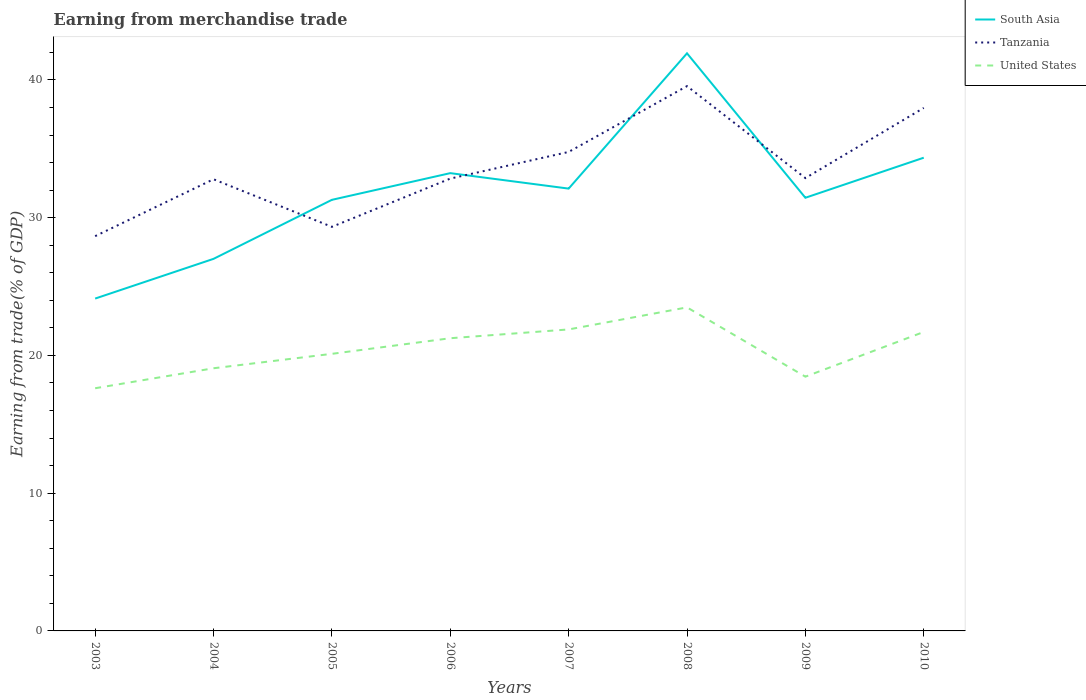Is the number of lines equal to the number of legend labels?
Give a very brief answer. Yes. Across all years, what is the maximum earnings from trade in Tanzania?
Give a very brief answer. 28.66. In which year was the earnings from trade in South Asia maximum?
Offer a terse response. 2003. What is the total earnings from trade in United States in the graph?
Keep it short and to the point. -3.37. What is the difference between the highest and the second highest earnings from trade in United States?
Provide a succinct answer. 5.87. What is the difference between the highest and the lowest earnings from trade in United States?
Ensure brevity in your answer.  4. How many lines are there?
Your response must be concise. 3. What is the difference between two consecutive major ticks on the Y-axis?
Provide a short and direct response. 10. Are the values on the major ticks of Y-axis written in scientific E-notation?
Provide a succinct answer. No. Does the graph contain any zero values?
Your answer should be compact. No. Where does the legend appear in the graph?
Your answer should be very brief. Top right. How many legend labels are there?
Provide a succinct answer. 3. How are the legend labels stacked?
Make the answer very short. Vertical. What is the title of the graph?
Provide a succinct answer. Earning from merchandise trade. Does "Bhutan" appear as one of the legend labels in the graph?
Ensure brevity in your answer.  No. What is the label or title of the X-axis?
Offer a terse response. Years. What is the label or title of the Y-axis?
Offer a very short reply. Earning from trade(% of GDP). What is the Earning from trade(% of GDP) of South Asia in 2003?
Keep it short and to the point. 24.13. What is the Earning from trade(% of GDP) in Tanzania in 2003?
Provide a succinct answer. 28.66. What is the Earning from trade(% of GDP) in United States in 2003?
Provide a short and direct response. 17.62. What is the Earning from trade(% of GDP) of South Asia in 2004?
Give a very brief answer. 27.01. What is the Earning from trade(% of GDP) in Tanzania in 2004?
Give a very brief answer. 32.79. What is the Earning from trade(% of GDP) of United States in 2004?
Offer a terse response. 19.07. What is the Earning from trade(% of GDP) in South Asia in 2005?
Your answer should be very brief. 31.29. What is the Earning from trade(% of GDP) of Tanzania in 2005?
Ensure brevity in your answer.  29.33. What is the Earning from trade(% of GDP) in United States in 2005?
Make the answer very short. 20.11. What is the Earning from trade(% of GDP) in South Asia in 2006?
Your answer should be compact. 33.23. What is the Earning from trade(% of GDP) of Tanzania in 2006?
Ensure brevity in your answer.  32.84. What is the Earning from trade(% of GDP) in United States in 2006?
Offer a very short reply. 21.25. What is the Earning from trade(% of GDP) in South Asia in 2007?
Offer a very short reply. 32.11. What is the Earning from trade(% of GDP) of Tanzania in 2007?
Provide a succinct answer. 34.77. What is the Earning from trade(% of GDP) in United States in 2007?
Your response must be concise. 21.89. What is the Earning from trade(% of GDP) of South Asia in 2008?
Make the answer very short. 41.93. What is the Earning from trade(% of GDP) in Tanzania in 2008?
Keep it short and to the point. 39.55. What is the Earning from trade(% of GDP) of United States in 2008?
Keep it short and to the point. 23.49. What is the Earning from trade(% of GDP) in South Asia in 2009?
Your answer should be very brief. 31.44. What is the Earning from trade(% of GDP) in Tanzania in 2009?
Your answer should be very brief. 32.87. What is the Earning from trade(% of GDP) in United States in 2009?
Make the answer very short. 18.46. What is the Earning from trade(% of GDP) in South Asia in 2010?
Your answer should be very brief. 34.35. What is the Earning from trade(% of GDP) of Tanzania in 2010?
Your answer should be compact. 37.97. What is the Earning from trade(% of GDP) of United States in 2010?
Your response must be concise. 21.7. Across all years, what is the maximum Earning from trade(% of GDP) of South Asia?
Your answer should be very brief. 41.93. Across all years, what is the maximum Earning from trade(% of GDP) of Tanzania?
Your answer should be compact. 39.55. Across all years, what is the maximum Earning from trade(% of GDP) in United States?
Ensure brevity in your answer.  23.49. Across all years, what is the minimum Earning from trade(% of GDP) of South Asia?
Provide a short and direct response. 24.13. Across all years, what is the minimum Earning from trade(% of GDP) of Tanzania?
Give a very brief answer. 28.66. Across all years, what is the minimum Earning from trade(% of GDP) of United States?
Offer a terse response. 17.62. What is the total Earning from trade(% of GDP) in South Asia in the graph?
Provide a short and direct response. 255.5. What is the total Earning from trade(% of GDP) in Tanzania in the graph?
Provide a succinct answer. 268.78. What is the total Earning from trade(% of GDP) of United States in the graph?
Provide a short and direct response. 163.58. What is the difference between the Earning from trade(% of GDP) in South Asia in 2003 and that in 2004?
Your answer should be very brief. -2.88. What is the difference between the Earning from trade(% of GDP) in Tanzania in 2003 and that in 2004?
Your response must be concise. -4.13. What is the difference between the Earning from trade(% of GDP) in United States in 2003 and that in 2004?
Provide a short and direct response. -1.45. What is the difference between the Earning from trade(% of GDP) of South Asia in 2003 and that in 2005?
Your answer should be very brief. -7.17. What is the difference between the Earning from trade(% of GDP) in Tanzania in 2003 and that in 2005?
Keep it short and to the point. -0.68. What is the difference between the Earning from trade(% of GDP) of United States in 2003 and that in 2005?
Your answer should be compact. -2.5. What is the difference between the Earning from trade(% of GDP) of South Asia in 2003 and that in 2006?
Your answer should be compact. -9.11. What is the difference between the Earning from trade(% of GDP) of Tanzania in 2003 and that in 2006?
Offer a terse response. -4.18. What is the difference between the Earning from trade(% of GDP) in United States in 2003 and that in 2006?
Ensure brevity in your answer.  -3.63. What is the difference between the Earning from trade(% of GDP) in South Asia in 2003 and that in 2007?
Your answer should be compact. -7.98. What is the difference between the Earning from trade(% of GDP) in Tanzania in 2003 and that in 2007?
Keep it short and to the point. -6.11. What is the difference between the Earning from trade(% of GDP) of United States in 2003 and that in 2007?
Your answer should be compact. -4.27. What is the difference between the Earning from trade(% of GDP) in South Asia in 2003 and that in 2008?
Provide a succinct answer. -17.8. What is the difference between the Earning from trade(% of GDP) of Tanzania in 2003 and that in 2008?
Provide a succinct answer. -10.89. What is the difference between the Earning from trade(% of GDP) of United States in 2003 and that in 2008?
Provide a short and direct response. -5.87. What is the difference between the Earning from trade(% of GDP) in South Asia in 2003 and that in 2009?
Provide a succinct answer. -7.32. What is the difference between the Earning from trade(% of GDP) of Tanzania in 2003 and that in 2009?
Give a very brief answer. -4.22. What is the difference between the Earning from trade(% of GDP) in United States in 2003 and that in 2009?
Make the answer very short. -0.84. What is the difference between the Earning from trade(% of GDP) of South Asia in 2003 and that in 2010?
Keep it short and to the point. -10.23. What is the difference between the Earning from trade(% of GDP) of Tanzania in 2003 and that in 2010?
Provide a short and direct response. -9.31. What is the difference between the Earning from trade(% of GDP) in United States in 2003 and that in 2010?
Provide a short and direct response. -4.09. What is the difference between the Earning from trade(% of GDP) of South Asia in 2004 and that in 2005?
Your response must be concise. -4.28. What is the difference between the Earning from trade(% of GDP) of Tanzania in 2004 and that in 2005?
Give a very brief answer. 3.45. What is the difference between the Earning from trade(% of GDP) in United States in 2004 and that in 2005?
Provide a succinct answer. -1.05. What is the difference between the Earning from trade(% of GDP) of South Asia in 2004 and that in 2006?
Your answer should be very brief. -6.22. What is the difference between the Earning from trade(% of GDP) in Tanzania in 2004 and that in 2006?
Your response must be concise. -0.05. What is the difference between the Earning from trade(% of GDP) in United States in 2004 and that in 2006?
Keep it short and to the point. -2.18. What is the difference between the Earning from trade(% of GDP) in South Asia in 2004 and that in 2007?
Keep it short and to the point. -5.1. What is the difference between the Earning from trade(% of GDP) in Tanzania in 2004 and that in 2007?
Keep it short and to the point. -1.98. What is the difference between the Earning from trade(% of GDP) in United States in 2004 and that in 2007?
Make the answer very short. -2.82. What is the difference between the Earning from trade(% of GDP) in South Asia in 2004 and that in 2008?
Your response must be concise. -14.92. What is the difference between the Earning from trade(% of GDP) of Tanzania in 2004 and that in 2008?
Keep it short and to the point. -6.76. What is the difference between the Earning from trade(% of GDP) of United States in 2004 and that in 2008?
Your response must be concise. -4.42. What is the difference between the Earning from trade(% of GDP) of South Asia in 2004 and that in 2009?
Offer a terse response. -4.44. What is the difference between the Earning from trade(% of GDP) of Tanzania in 2004 and that in 2009?
Make the answer very short. -0.09. What is the difference between the Earning from trade(% of GDP) of United States in 2004 and that in 2009?
Your response must be concise. 0.61. What is the difference between the Earning from trade(% of GDP) of South Asia in 2004 and that in 2010?
Make the answer very short. -7.34. What is the difference between the Earning from trade(% of GDP) of Tanzania in 2004 and that in 2010?
Keep it short and to the point. -5.18. What is the difference between the Earning from trade(% of GDP) in United States in 2004 and that in 2010?
Your answer should be compact. -2.63. What is the difference between the Earning from trade(% of GDP) of South Asia in 2005 and that in 2006?
Offer a terse response. -1.94. What is the difference between the Earning from trade(% of GDP) of Tanzania in 2005 and that in 2006?
Offer a terse response. -3.5. What is the difference between the Earning from trade(% of GDP) in United States in 2005 and that in 2006?
Offer a very short reply. -1.13. What is the difference between the Earning from trade(% of GDP) in South Asia in 2005 and that in 2007?
Make the answer very short. -0.81. What is the difference between the Earning from trade(% of GDP) in Tanzania in 2005 and that in 2007?
Keep it short and to the point. -5.44. What is the difference between the Earning from trade(% of GDP) of United States in 2005 and that in 2007?
Your answer should be very brief. -1.77. What is the difference between the Earning from trade(% of GDP) of South Asia in 2005 and that in 2008?
Keep it short and to the point. -10.64. What is the difference between the Earning from trade(% of GDP) in Tanzania in 2005 and that in 2008?
Offer a terse response. -10.21. What is the difference between the Earning from trade(% of GDP) in United States in 2005 and that in 2008?
Make the answer very short. -3.37. What is the difference between the Earning from trade(% of GDP) in South Asia in 2005 and that in 2009?
Your answer should be compact. -0.15. What is the difference between the Earning from trade(% of GDP) in Tanzania in 2005 and that in 2009?
Ensure brevity in your answer.  -3.54. What is the difference between the Earning from trade(% of GDP) of United States in 2005 and that in 2009?
Your answer should be compact. 1.66. What is the difference between the Earning from trade(% of GDP) in South Asia in 2005 and that in 2010?
Keep it short and to the point. -3.06. What is the difference between the Earning from trade(% of GDP) of Tanzania in 2005 and that in 2010?
Offer a very short reply. -8.63. What is the difference between the Earning from trade(% of GDP) of United States in 2005 and that in 2010?
Your answer should be very brief. -1.59. What is the difference between the Earning from trade(% of GDP) of South Asia in 2006 and that in 2007?
Your answer should be very brief. 1.12. What is the difference between the Earning from trade(% of GDP) in Tanzania in 2006 and that in 2007?
Provide a succinct answer. -1.94. What is the difference between the Earning from trade(% of GDP) in United States in 2006 and that in 2007?
Provide a succinct answer. -0.64. What is the difference between the Earning from trade(% of GDP) of South Asia in 2006 and that in 2008?
Your answer should be very brief. -8.7. What is the difference between the Earning from trade(% of GDP) in Tanzania in 2006 and that in 2008?
Offer a terse response. -6.71. What is the difference between the Earning from trade(% of GDP) of United States in 2006 and that in 2008?
Keep it short and to the point. -2.24. What is the difference between the Earning from trade(% of GDP) in South Asia in 2006 and that in 2009?
Your response must be concise. 1.79. What is the difference between the Earning from trade(% of GDP) of Tanzania in 2006 and that in 2009?
Keep it short and to the point. -0.04. What is the difference between the Earning from trade(% of GDP) of United States in 2006 and that in 2009?
Keep it short and to the point. 2.79. What is the difference between the Earning from trade(% of GDP) of South Asia in 2006 and that in 2010?
Give a very brief answer. -1.12. What is the difference between the Earning from trade(% of GDP) in Tanzania in 2006 and that in 2010?
Your response must be concise. -5.13. What is the difference between the Earning from trade(% of GDP) of United States in 2006 and that in 2010?
Your response must be concise. -0.46. What is the difference between the Earning from trade(% of GDP) in South Asia in 2007 and that in 2008?
Provide a short and direct response. -9.82. What is the difference between the Earning from trade(% of GDP) of Tanzania in 2007 and that in 2008?
Your response must be concise. -4.78. What is the difference between the Earning from trade(% of GDP) of United States in 2007 and that in 2008?
Your answer should be compact. -1.6. What is the difference between the Earning from trade(% of GDP) of South Asia in 2007 and that in 2009?
Your answer should be compact. 0.66. What is the difference between the Earning from trade(% of GDP) of Tanzania in 2007 and that in 2009?
Your response must be concise. 1.9. What is the difference between the Earning from trade(% of GDP) of United States in 2007 and that in 2009?
Offer a very short reply. 3.43. What is the difference between the Earning from trade(% of GDP) in South Asia in 2007 and that in 2010?
Your response must be concise. -2.24. What is the difference between the Earning from trade(% of GDP) in Tanzania in 2007 and that in 2010?
Provide a short and direct response. -3.2. What is the difference between the Earning from trade(% of GDP) in United States in 2007 and that in 2010?
Provide a short and direct response. 0.18. What is the difference between the Earning from trade(% of GDP) of South Asia in 2008 and that in 2009?
Keep it short and to the point. 10.48. What is the difference between the Earning from trade(% of GDP) of Tanzania in 2008 and that in 2009?
Offer a very short reply. 6.67. What is the difference between the Earning from trade(% of GDP) of United States in 2008 and that in 2009?
Provide a succinct answer. 5.03. What is the difference between the Earning from trade(% of GDP) of South Asia in 2008 and that in 2010?
Your response must be concise. 7.58. What is the difference between the Earning from trade(% of GDP) of Tanzania in 2008 and that in 2010?
Keep it short and to the point. 1.58. What is the difference between the Earning from trade(% of GDP) of United States in 2008 and that in 2010?
Provide a succinct answer. 1.78. What is the difference between the Earning from trade(% of GDP) of South Asia in 2009 and that in 2010?
Ensure brevity in your answer.  -2.91. What is the difference between the Earning from trade(% of GDP) in Tanzania in 2009 and that in 2010?
Your answer should be very brief. -5.09. What is the difference between the Earning from trade(% of GDP) in United States in 2009 and that in 2010?
Your answer should be compact. -3.25. What is the difference between the Earning from trade(% of GDP) of South Asia in 2003 and the Earning from trade(% of GDP) of Tanzania in 2004?
Your response must be concise. -8.66. What is the difference between the Earning from trade(% of GDP) in South Asia in 2003 and the Earning from trade(% of GDP) in United States in 2004?
Keep it short and to the point. 5.06. What is the difference between the Earning from trade(% of GDP) of Tanzania in 2003 and the Earning from trade(% of GDP) of United States in 2004?
Offer a terse response. 9.59. What is the difference between the Earning from trade(% of GDP) in South Asia in 2003 and the Earning from trade(% of GDP) in Tanzania in 2005?
Ensure brevity in your answer.  -5.21. What is the difference between the Earning from trade(% of GDP) in South Asia in 2003 and the Earning from trade(% of GDP) in United States in 2005?
Your answer should be compact. 4.01. What is the difference between the Earning from trade(% of GDP) of Tanzania in 2003 and the Earning from trade(% of GDP) of United States in 2005?
Your response must be concise. 8.54. What is the difference between the Earning from trade(% of GDP) of South Asia in 2003 and the Earning from trade(% of GDP) of Tanzania in 2006?
Your answer should be compact. -8.71. What is the difference between the Earning from trade(% of GDP) in South Asia in 2003 and the Earning from trade(% of GDP) in United States in 2006?
Ensure brevity in your answer.  2.88. What is the difference between the Earning from trade(% of GDP) of Tanzania in 2003 and the Earning from trade(% of GDP) of United States in 2006?
Provide a succinct answer. 7.41. What is the difference between the Earning from trade(% of GDP) of South Asia in 2003 and the Earning from trade(% of GDP) of Tanzania in 2007?
Give a very brief answer. -10.64. What is the difference between the Earning from trade(% of GDP) in South Asia in 2003 and the Earning from trade(% of GDP) in United States in 2007?
Your answer should be compact. 2.24. What is the difference between the Earning from trade(% of GDP) of Tanzania in 2003 and the Earning from trade(% of GDP) of United States in 2007?
Keep it short and to the point. 6.77. What is the difference between the Earning from trade(% of GDP) in South Asia in 2003 and the Earning from trade(% of GDP) in Tanzania in 2008?
Provide a succinct answer. -15.42. What is the difference between the Earning from trade(% of GDP) of South Asia in 2003 and the Earning from trade(% of GDP) of United States in 2008?
Ensure brevity in your answer.  0.64. What is the difference between the Earning from trade(% of GDP) in Tanzania in 2003 and the Earning from trade(% of GDP) in United States in 2008?
Provide a short and direct response. 5.17. What is the difference between the Earning from trade(% of GDP) of South Asia in 2003 and the Earning from trade(% of GDP) of Tanzania in 2009?
Your response must be concise. -8.75. What is the difference between the Earning from trade(% of GDP) of South Asia in 2003 and the Earning from trade(% of GDP) of United States in 2009?
Provide a short and direct response. 5.67. What is the difference between the Earning from trade(% of GDP) in Tanzania in 2003 and the Earning from trade(% of GDP) in United States in 2009?
Offer a terse response. 10.2. What is the difference between the Earning from trade(% of GDP) of South Asia in 2003 and the Earning from trade(% of GDP) of Tanzania in 2010?
Offer a terse response. -13.84. What is the difference between the Earning from trade(% of GDP) of South Asia in 2003 and the Earning from trade(% of GDP) of United States in 2010?
Make the answer very short. 2.42. What is the difference between the Earning from trade(% of GDP) of Tanzania in 2003 and the Earning from trade(% of GDP) of United States in 2010?
Provide a short and direct response. 6.96. What is the difference between the Earning from trade(% of GDP) in South Asia in 2004 and the Earning from trade(% of GDP) in Tanzania in 2005?
Provide a short and direct response. -2.32. What is the difference between the Earning from trade(% of GDP) in South Asia in 2004 and the Earning from trade(% of GDP) in United States in 2005?
Your response must be concise. 6.89. What is the difference between the Earning from trade(% of GDP) of Tanzania in 2004 and the Earning from trade(% of GDP) of United States in 2005?
Offer a terse response. 12.67. What is the difference between the Earning from trade(% of GDP) in South Asia in 2004 and the Earning from trade(% of GDP) in Tanzania in 2006?
Keep it short and to the point. -5.83. What is the difference between the Earning from trade(% of GDP) of South Asia in 2004 and the Earning from trade(% of GDP) of United States in 2006?
Your answer should be very brief. 5.76. What is the difference between the Earning from trade(% of GDP) in Tanzania in 2004 and the Earning from trade(% of GDP) in United States in 2006?
Keep it short and to the point. 11.54. What is the difference between the Earning from trade(% of GDP) in South Asia in 2004 and the Earning from trade(% of GDP) in Tanzania in 2007?
Give a very brief answer. -7.76. What is the difference between the Earning from trade(% of GDP) in South Asia in 2004 and the Earning from trade(% of GDP) in United States in 2007?
Give a very brief answer. 5.12. What is the difference between the Earning from trade(% of GDP) of Tanzania in 2004 and the Earning from trade(% of GDP) of United States in 2007?
Make the answer very short. 10.9. What is the difference between the Earning from trade(% of GDP) of South Asia in 2004 and the Earning from trade(% of GDP) of Tanzania in 2008?
Ensure brevity in your answer.  -12.54. What is the difference between the Earning from trade(% of GDP) in South Asia in 2004 and the Earning from trade(% of GDP) in United States in 2008?
Provide a short and direct response. 3.52. What is the difference between the Earning from trade(% of GDP) of Tanzania in 2004 and the Earning from trade(% of GDP) of United States in 2008?
Make the answer very short. 9.3. What is the difference between the Earning from trade(% of GDP) in South Asia in 2004 and the Earning from trade(% of GDP) in Tanzania in 2009?
Your response must be concise. -5.86. What is the difference between the Earning from trade(% of GDP) of South Asia in 2004 and the Earning from trade(% of GDP) of United States in 2009?
Keep it short and to the point. 8.55. What is the difference between the Earning from trade(% of GDP) in Tanzania in 2004 and the Earning from trade(% of GDP) in United States in 2009?
Ensure brevity in your answer.  14.33. What is the difference between the Earning from trade(% of GDP) of South Asia in 2004 and the Earning from trade(% of GDP) of Tanzania in 2010?
Your answer should be compact. -10.96. What is the difference between the Earning from trade(% of GDP) in South Asia in 2004 and the Earning from trade(% of GDP) in United States in 2010?
Keep it short and to the point. 5.31. What is the difference between the Earning from trade(% of GDP) of Tanzania in 2004 and the Earning from trade(% of GDP) of United States in 2010?
Offer a very short reply. 11.09. What is the difference between the Earning from trade(% of GDP) in South Asia in 2005 and the Earning from trade(% of GDP) in Tanzania in 2006?
Give a very brief answer. -1.54. What is the difference between the Earning from trade(% of GDP) in South Asia in 2005 and the Earning from trade(% of GDP) in United States in 2006?
Provide a succinct answer. 10.05. What is the difference between the Earning from trade(% of GDP) of Tanzania in 2005 and the Earning from trade(% of GDP) of United States in 2006?
Your answer should be compact. 8.09. What is the difference between the Earning from trade(% of GDP) of South Asia in 2005 and the Earning from trade(% of GDP) of Tanzania in 2007?
Offer a terse response. -3.48. What is the difference between the Earning from trade(% of GDP) of South Asia in 2005 and the Earning from trade(% of GDP) of United States in 2007?
Provide a succinct answer. 9.41. What is the difference between the Earning from trade(% of GDP) of Tanzania in 2005 and the Earning from trade(% of GDP) of United States in 2007?
Keep it short and to the point. 7.45. What is the difference between the Earning from trade(% of GDP) in South Asia in 2005 and the Earning from trade(% of GDP) in Tanzania in 2008?
Ensure brevity in your answer.  -8.25. What is the difference between the Earning from trade(% of GDP) in South Asia in 2005 and the Earning from trade(% of GDP) in United States in 2008?
Your answer should be very brief. 7.81. What is the difference between the Earning from trade(% of GDP) in Tanzania in 2005 and the Earning from trade(% of GDP) in United States in 2008?
Ensure brevity in your answer.  5.85. What is the difference between the Earning from trade(% of GDP) in South Asia in 2005 and the Earning from trade(% of GDP) in Tanzania in 2009?
Offer a terse response. -1.58. What is the difference between the Earning from trade(% of GDP) of South Asia in 2005 and the Earning from trade(% of GDP) of United States in 2009?
Ensure brevity in your answer.  12.84. What is the difference between the Earning from trade(% of GDP) of Tanzania in 2005 and the Earning from trade(% of GDP) of United States in 2009?
Offer a terse response. 10.88. What is the difference between the Earning from trade(% of GDP) in South Asia in 2005 and the Earning from trade(% of GDP) in Tanzania in 2010?
Keep it short and to the point. -6.67. What is the difference between the Earning from trade(% of GDP) in South Asia in 2005 and the Earning from trade(% of GDP) in United States in 2010?
Offer a terse response. 9.59. What is the difference between the Earning from trade(% of GDP) in Tanzania in 2005 and the Earning from trade(% of GDP) in United States in 2010?
Give a very brief answer. 7.63. What is the difference between the Earning from trade(% of GDP) in South Asia in 2006 and the Earning from trade(% of GDP) in Tanzania in 2007?
Give a very brief answer. -1.54. What is the difference between the Earning from trade(% of GDP) of South Asia in 2006 and the Earning from trade(% of GDP) of United States in 2007?
Offer a terse response. 11.35. What is the difference between the Earning from trade(% of GDP) of Tanzania in 2006 and the Earning from trade(% of GDP) of United States in 2007?
Offer a terse response. 10.95. What is the difference between the Earning from trade(% of GDP) in South Asia in 2006 and the Earning from trade(% of GDP) in Tanzania in 2008?
Your answer should be compact. -6.32. What is the difference between the Earning from trade(% of GDP) of South Asia in 2006 and the Earning from trade(% of GDP) of United States in 2008?
Your answer should be very brief. 9.74. What is the difference between the Earning from trade(% of GDP) in Tanzania in 2006 and the Earning from trade(% of GDP) in United States in 2008?
Your answer should be very brief. 9.35. What is the difference between the Earning from trade(% of GDP) in South Asia in 2006 and the Earning from trade(% of GDP) in Tanzania in 2009?
Ensure brevity in your answer.  0.36. What is the difference between the Earning from trade(% of GDP) of South Asia in 2006 and the Earning from trade(% of GDP) of United States in 2009?
Your answer should be compact. 14.77. What is the difference between the Earning from trade(% of GDP) of Tanzania in 2006 and the Earning from trade(% of GDP) of United States in 2009?
Offer a terse response. 14.38. What is the difference between the Earning from trade(% of GDP) in South Asia in 2006 and the Earning from trade(% of GDP) in Tanzania in 2010?
Provide a succinct answer. -4.74. What is the difference between the Earning from trade(% of GDP) of South Asia in 2006 and the Earning from trade(% of GDP) of United States in 2010?
Your response must be concise. 11.53. What is the difference between the Earning from trade(% of GDP) of Tanzania in 2006 and the Earning from trade(% of GDP) of United States in 2010?
Give a very brief answer. 11.13. What is the difference between the Earning from trade(% of GDP) of South Asia in 2007 and the Earning from trade(% of GDP) of Tanzania in 2008?
Provide a succinct answer. -7.44. What is the difference between the Earning from trade(% of GDP) of South Asia in 2007 and the Earning from trade(% of GDP) of United States in 2008?
Your answer should be very brief. 8.62. What is the difference between the Earning from trade(% of GDP) in Tanzania in 2007 and the Earning from trade(% of GDP) in United States in 2008?
Your response must be concise. 11.28. What is the difference between the Earning from trade(% of GDP) of South Asia in 2007 and the Earning from trade(% of GDP) of Tanzania in 2009?
Keep it short and to the point. -0.76. What is the difference between the Earning from trade(% of GDP) in South Asia in 2007 and the Earning from trade(% of GDP) in United States in 2009?
Provide a short and direct response. 13.65. What is the difference between the Earning from trade(% of GDP) of Tanzania in 2007 and the Earning from trade(% of GDP) of United States in 2009?
Keep it short and to the point. 16.31. What is the difference between the Earning from trade(% of GDP) in South Asia in 2007 and the Earning from trade(% of GDP) in Tanzania in 2010?
Provide a succinct answer. -5.86. What is the difference between the Earning from trade(% of GDP) of South Asia in 2007 and the Earning from trade(% of GDP) of United States in 2010?
Provide a short and direct response. 10.41. What is the difference between the Earning from trade(% of GDP) in Tanzania in 2007 and the Earning from trade(% of GDP) in United States in 2010?
Offer a terse response. 13.07. What is the difference between the Earning from trade(% of GDP) of South Asia in 2008 and the Earning from trade(% of GDP) of Tanzania in 2009?
Provide a short and direct response. 9.06. What is the difference between the Earning from trade(% of GDP) in South Asia in 2008 and the Earning from trade(% of GDP) in United States in 2009?
Give a very brief answer. 23.47. What is the difference between the Earning from trade(% of GDP) in Tanzania in 2008 and the Earning from trade(% of GDP) in United States in 2009?
Offer a very short reply. 21.09. What is the difference between the Earning from trade(% of GDP) in South Asia in 2008 and the Earning from trade(% of GDP) in Tanzania in 2010?
Give a very brief answer. 3.96. What is the difference between the Earning from trade(% of GDP) of South Asia in 2008 and the Earning from trade(% of GDP) of United States in 2010?
Your answer should be compact. 20.23. What is the difference between the Earning from trade(% of GDP) of Tanzania in 2008 and the Earning from trade(% of GDP) of United States in 2010?
Ensure brevity in your answer.  17.85. What is the difference between the Earning from trade(% of GDP) of South Asia in 2009 and the Earning from trade(% of GDP) of Tanzania in 2010?
Provide a short and direct response. -6.52. What is the difference between the Earning from trade(% of GDP) in South Asia in 2009 and the Earning from trade(% of GDP) in United States in 2010?
Offer a very short reply. 9.74. What is the difference between the Earning from trade(% of GDP) of Tanzania in 2009 and the Earning from trade(% of GDP) of United States in 2010?
Your answer should be compact. 11.17. What is the average Earning from trade(% of GDP) in South Asia per year?
Your response must be concise. 31.94. What is the average Earning from trade(% of GDP) of Tanzania per year?
Provide a succinct answer. 33.6. What is the average Earning from trade(% of GDP) of United States per year?
Your answer should be very brief. 20.45. In the year 2003, what is the difference between the Earning from trade(% of GDP) in South Asia and Earning from trade(% of GDP) in Tanzania?
Offer a terse response. -4.53. In the year 2003, what is the difference between the Earning from trade(% of GDP) in South Asia and Earning from trade(% of GDP) in United States?
Your answer should be very brief. 6.51. In the year 2003, what is the difference between the Earning from trade(% of GDP) in Tanzania and Earning from trade(% of GDP) in United States?
Keep it short and to the point. 11.04. In the year 2004, what is the difference between the Earning from trade(% of GDP) in South Asia and Earning from trade(% of GDP) in Tanzania?
Offer a terse response. -5.78. In the year 2004, what is the difference between the Earning from trade(% of GDP) of South Asia and Earning from trade(% of GDP) of United States?
Give a very brief answer. 7.94. In the year 2004, what is the difference between the Earning from trade(% of GDP) in Tanzania and Earning from trade(% of GDP) in United States?
Your response must be concise. 13.72. In the year 2005, what is the difference between the Earning from trade(% of GDP) of South Asia and Earning from trade(% of GDP) of Tanzania?
Ensure brevity in your answer.  1.96. In the year 2005, what is the difference between the Earning from trade(% of GDP) in South Asia and Earning from trade(% of GDP) in United States?
Offer a terse response. 11.18. In the year 2005, what is the difference between the Earning from trade(% of GDP) in Tanzania and Earning from trade(% of GDP) in United States?
Offer a very short reply. 9.22. In the year 2006, what is the difference between the Earning from trade(% of GDP) of South Asia and Earning from trade(% of GDP) of Tanzania?
Provide a short and direct response. 0.4. In the year 2006, what is the difference between the Earning from trade(% of GDP) of South Asia and Earning from trade(% of GDP) of United States?
Offer a very short reply. 11.98. In the year 2006, what is the difference between the Earning from trade(% of GDP) of Tanzania and Earning from trade(% of GDP) of United States?
Offer a very short reply. 11.59. In the year 2007, what is the difference between the Earning from trade(% of GDP) in South Asia and Earning from trade(% of GDP) in Tanzania?
Offer a very short reply. -2.66. In the year 2007, what is the difference between the Earning from trade(% of GDP) of South Asia and Earning from trade(% of GDP) of United States?
Provide a succinct answer. 10.22. In the year 2007, what is the difference between the Earning from trade(% of GDP) in Tanzania and Earning from trade(% of GDP) in United States?
Provide a short and direct response. 12.88. In the year 2008, what is the difference between the Earning from trade(% of GDP) in South Asia and Earning from trade(% of GDP) in Tanzania?
Keep it short and to the point. 2.38. In the year 2008, what is the difference between the Earning from trade(% of GDP) in South Asia and Earning from trade(% of GDP) in United States?
Your answer should be compact. 18.44. In the year 2008, what is the difference between the Earning from trade(% of GDP) of Tanzania and Earning from trade(% of GDP) of United States?
Keep it short and to the point. 16.06. In the year 2009, what is the difference between the Earning from trade(% of GDP) of South Asia and Earning from trade(% of GDP) of Tanzania?
Provide a succinct answer. -1.43. In the year 2009, what is the difference between the Earning from trade(% of GDP) in South Asia and Earning from trade(% of GDP) in United States?
Your answer should be compact. 12.99. In the year 2009, what is the difference between the Earning from trade(% of GDP) of Tanzania and Earning from trade(% of GDP) of United States?
Your response must be concise. 14.42. In the year 2010, what is the difference between the Earning from trade(% of GDP) of South Asia and Earning from trade(% of GDP) of Tanzania?
Offer a very short reply. -3.61. In the year 2010, what is the difference between the Earning from trade(% of GDP) of South Asia and Earning from trade(% of GDP) of United States?
Keep it short and to the point. 12.65. In the year 2010, what is the difference between the Earning from trade(% of GDP) in Tanzania and Earning from trade(% of GDP) in United States?
Offer a very short reply. 16.26. What is the ratio of the Earning from trade(% of GDP) in South Asia in 2003 to that in 2004?
Ensure brevity in your answer.  0.89. What is the ratio of the Earning from trade(% of GDP) of Tanzania in 2003 to that in 2004?
Offer a very short reply. 0.87. What is the ratio of the Earning from trade(% of GDP) of United States in 2003 to that in 2004?
Ensure brevity in your answer.  0.92. What is the ratio of the Earning from trade(% of GDP) of South Asia in 2003 to that in 2005?
Keep it short and to the point. 0.77. What is the ratio of the Earning from trade(% of GDP) in United States in 2003 to that in 2005?
Ensure brevity in your answer.  0.88. What is the ratio of the Earning from trade(% of GDP) of South Asia in 2003 to that in 2006?
Give a very brief answer. 0.73. What is the ratio of the Earning from trade(% of GDP) in Tanzania in 2003 to that in 2006?
Offer a very short reply. 0.87. What is the ratio of the Earning from trade(% of GDP) of United States in 2003 to that in 2006?
Keep it short and to the point. 0.83. What is the ratio of the Earning from trade(% of GDP) of South Asia in 2003 to that in 2007?
Your answer should be very brief. 0.75. What is the ratio of the Earning from trade(% of GDP) of Tanzania in 2003 to that in 2007?
Give a very brief answer. 0.82. What is the ratio of the Earning from trade(% of GDP) in United States in 2003 to that in 2007?
Make the answer very short. 0.8. What is the ratio of the Earning from trade(% of GDP) in South Asia in 2003 to that in 2008?
Ensure brevity in your answer.  0.58. What is the ratio of the Earning from trade(% of GDP) of Tanzania in 2003 to that in 2008?
Give a very brief answer. 0.72. What is the ratio of the Earning from trade(% of GDP) in United States in 2003 to that in 2008?
Your answer should be very brief. 0.75. What is the ratio of the Earning from trade(% of GDP) in South Asia in 2003 to that in 2009?
Provide a succinct answer. 0.77. What is the ratio of the Earning from trade(% of GDP) in Tanzania in 2003 to that in 2009?
Make the answer very short. 0.87. What is the ratio of the Earning from trade(% of GDP) in United States in 2003 to that in 2009?
Keep it short and to the point. 0.95. What is the ratio of the Earning from trade(% of GDP) in South Asia in 2003 to that in 2010?
Give a very brief answer. 0.7. What is the ratio of the Earning from trade(% of GDP) of Tanzania in 2003 to that in 2010?
Your response must be concise. 0.75. What is the ratio of the Earning from trade(% of GDP) in United States in 2003 to that in 2010?
Provide a short and direct response. 0.81. What is the ratio of the Earning from trade(% of GDP) in South Asia in 2004 to that in 2005?
Your answer should be compact. 0.86. What is the ratio of the Earning from trade(% of GDP) in Tanzania in 2004 to that in 2005?
Your answer should be compact. 1.12. What is the ratio of the Earning from trade(% of GDP) of United States in 2004 to that in 2005?
Offer a terse response. 0.95. What is the ratio of the Earning from trade(% of GDP) in South Asia in 2004 to that in 2006?
Your response must be concise. 0.81. What is the ratio of the Earning from trade(% of GDP) in United States in 2004 to that in 2006?
Offer a very short reply. 0.9. What is the ratio of the Earning from trade(% of GDP) in South Asia in 2004 to that in 2007?
Give a very brief answer. 0.84. What is the ratio of the Earning from trade(% of GDP) in Tanzania in 2004 to that in 2007?
Make the answer very short. 0.94. What is the ratio of the Earning from trade(% of GDP) of United States in 2004 to that in 2007?
Your response must be concise. 0.87. What is the ratio of the Earning from trade(% of GDP) of South Asia in 2004 to that in 2008?
Your answer should be compact. 0.64. What is the ratio of the Earning from trade(% of GDP) in Tanzania in 2004 to that in 2008?
Provide a succinct answer. 0.83. What is the ratio of the Earning from trade(% of GDP) in United States in 2004 to that in 2008?
Provide a succinct answer. 0.81. What is the ratio of the Earning from trade(% of GDP) in South Asia in 2004 to that in 2009?
Offer a very short reply. 0.86. What is the ratio of the Earning from trade(% of GDP) of Tanzania in 2004 to that in 2009?
Ensure brevity in your answer.  1. What is the ratio of the Earning from trade(% of GDP) in United States in 2004 to that in 2009?
Give a very brief answer. 1.03. What is the ratio of the Earning from trade(% of GDP) in South Asia in 2004 to that in 2010?
Ensure brevity in your answer.  0.79. What is the ratio of the Earning from trade(% of GDP) in Tanzania in 2004 to that in 2010?
Offer a terse response. 0.86. What is the ratio of the Earning from trade(% of GDP) of United States in 2004 to that in 2010?
Offer a terse response. 0.88. What is the ratio of the Earning from trade(% of GDP) of South Asia in 2005 to that in 2006?
Your answer should be compact. 0.94. What is the ratio of the Earning from trade(% of GDP) in Tanzania in 2005 to that in 2006?
Provide a succinct answer. 0.89. What is the ratio of the Earning from trade(% of GDP) of United States in 2005 to that in 2006?
Offer a terse response. 0.95. What is the ratio of the Earning from trade(% of GDP) in South Asia in 2005 to that in 2007?
Give a very brief answer. 0.97. What is the ratio of the Earning from trade(% of GDP) in Tanzania in 2005 to that in 2007?
Offer a terse response. 0.84. What is the ratio of the Earning from trade(% of GDP) of United States in 2005 to that in 2007?
Your answer should be very brief. 0.92. What is the ratio of the Earning from trade(% of GDP) of South Asia in 2005 to that in 2008?
Make the answer very short. 0.75. What is the ratio of the Earning from trade(% of GDP) in Tanzania in 2005 to that in 2008?
Offer a very short reply. 0.74. What is the ratio of the Earning from trade(% of GDP) in United States in 2005 to that in 2008?
Make the answer very short. 0.86. What is the ratio of the Earning from trade(% of GDP) of Tanzania in 2005 to that in 2009?
Make the answer very short. 0.89. What is the ratio of the Earning from trade(% of GDP) of United States in 2005 to that in 2009?
Give a very brief answer. 1.09. What is the ratio of the Earning from trade(% of GDP) of South Asia in 2005 to that in 2010?
Keep it short and to the point. 0.91. What is the ratio of the Earning from trade(% of GDP) in Tanzania in 2005 to that in 2010?
Make the answer very short. 0.77. What is the ratio of the Earning from trade(% of GDP) in United States in 2005 to that in 2010?
Offer a very short reply. 0.93. What is the ratio of the Earning from trade(% of GDP) in South Asia in 2006 to that in 2007?
Offer a very short reply. 1.03. What is the ratio of the Earning from trade(% of GDP) in Tanzania in 2006 to that in 2007?
Offer a very short reply. 0.94. What is the ratio of the Earning from trade(% of GDP) in United States in 2006 to that in 2007?
Your response must be concise. 0.97. What is the ratio of the Earning from trade(% of GDP) in South Asia in 2006 to that in 2008?
Offer a terse response. 0.79. What is the ratio of the Earning from trade(% of GDP) of Tanzania in 2006 to that in 2008?
Make the answer very short. 0.83. What is the ratio of the Earning from trade(% of GDP) in United States in 2006 to that in 2008?
Provide a succinct answer. 0.9. What is the ratio of the Earning from trade(% of GDP) of South Asia in 2006 to that in 2009?
Provide a short and direct response. 1.06. What is the ratio of the Earning from trade(% of GDP) in United States in 2006 to that in 2009?
Provide a short and direct response. 1.15. What is the ratio of the Earning from trade(% of GDP) in South Asia in 2006 to that in 2010?
Make the answer very short. 0.97. What is the ratio of the Earning from trade(% of GDP) in Tanzania in 2006 to that in 2010?
Provide a short and direct response. 0.86. What is the ratio of the Earning from trade(% of GDP) in South Asia in 2007 to that in 2008?
Provide a short and direct response. 0.77. What is the ratio of the Earning from trade(% of GDP) in Tanzania in 2007 to that in 2008?
Offer a terse response. 0.88. What is the ratio of the Earning from trade(% of GDP) in United States in 2007 to that in 2008?
Ensure brevity in your answer.  0.93. What is the ratio of the Earning from trade(% of GDP) in South Asia in 2007 to that in 2009?
Your answer should be very brief. 1.02. What is the ratio of the Earning from trade(% of GDP) in Tanzania in 2007 to that in 2009?
Ensure brevity in your answer.  1.06. What is the ratio of the Earning from trade(% of GDP) in United States in 2007 to that in 2009?
Keep it short and to the point. 1.19. What is the ratio of the Earning from trade(% of GDP) of South Asia in 2007 to that in 2010?
Make the answer very short. 0.93. What is the ratio of the Earning from trade(% of GDP) of Tanzania in 2007 to that in 2010?
Offer a terse response. 0.92. What is the ratio of the Earning from trade(% of GDP) in United States in 2007 to that in 2010?
Your answer should be compact. 1.01. What is the ratio of the Earning from trade(% of GDP) of South Asia in 2008 to that in 2009?
Give a very brief answer. 1.33. What is the ratio of the Earning from trade(% of GDP) of Tanzania in 2008 to that in 2009?
Your answer should be compact. 1.2. What is the ratio of the Earning from trade(% of GDP) in United States in 2008 to that in 2009?
Keep it short and to the point. 1.27. What is the ratio of the Earning from trade(% of GDP) of South Asia in 2008 to that in 2010?
Ensure brevity in your answer.  1.22. What is the ratio of the Earning from trade(% of GDP) in Tanzania in 2008 to that in 2010?
Your answer should be compact. 1.04. What is the ratio of the Earning from trade(% of GDP) of United States in 2008 to that in 2010?
Ensure brevity in your answer.  1.08. What is the ratio of the Earning from trade(% of GDP) in South Asia in 2009 to that in 2010?
Make the answer very short. 0.92. What is the ratio of the Earning from trade(% of GDP) of Tanzania in 2009 to that in 2010?
Your answer should be compact. 0.87. What is the ratio of the Earning from trade(% of GDP) of United States in 2009 to that in 2010?
Make the answer very short. 0.85. What is the difference between the highest and the second highest Earning from trade(% of GDP) of South Asia?
Ensure brevity in your answer.  7.58. What is the difference between the highest and the second highest Earning from trade(% of GDP) of Tanzania?
Your answer should be very brief. 1.58. What is the difference between the highest and the second highest Earning from trade(% of GDP) in United States?
Your answer should be compact. 1.6. What is the difference between the highest and the lowest Earning from trade(% of GDP) in South Asia?
Offer a terse response. 17.8. What is the difference between the highest and the lowest Earning from trade(% of GDP) in Tanzania?
Make the answer very short. 10.89. What is the difference between the highest and the lowest Earning from trade(% of GDP) in United States?
Your response must be concise. 5.87. 